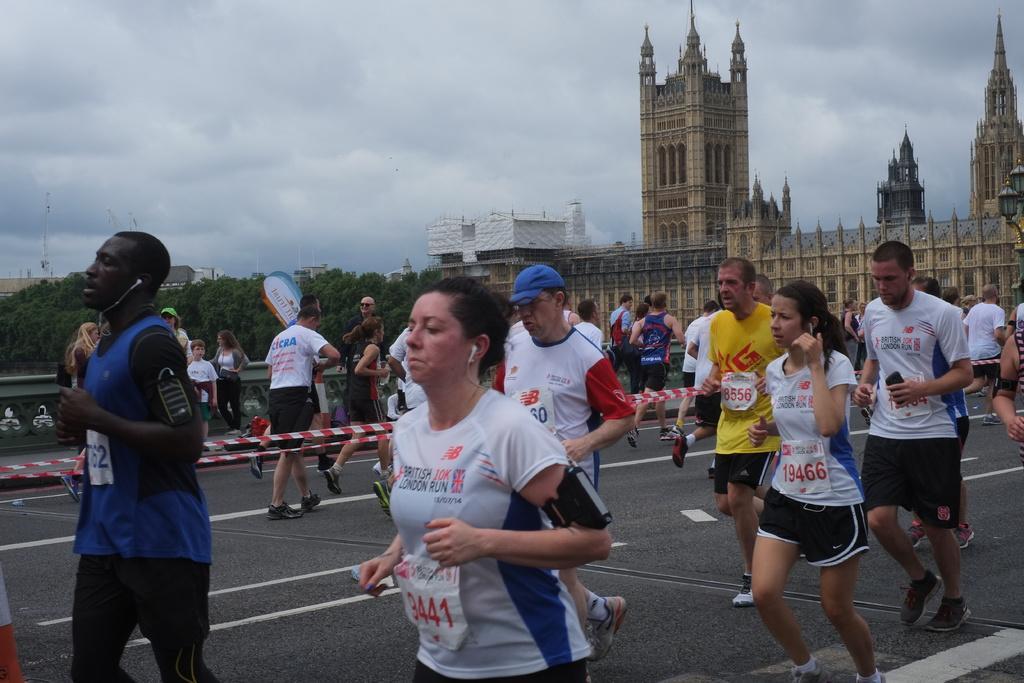Can you describe this image briefly? In this image, we can see a few people. We can see some buildings, trees, poles. We can see some ribbons and the sky with clouds. We can see the ground. 